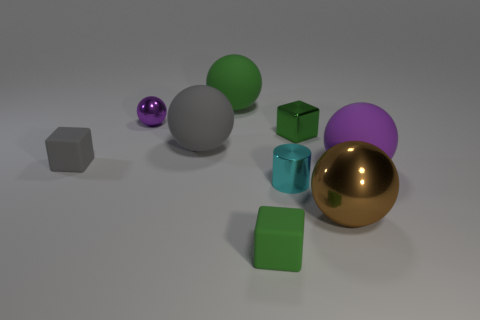What is the shape of the purple shiny thing? The purple shiny object in the image is a sphere, which is a perfectly round geometrical object in three-dimensional space, similar to the shape of a round ball. 